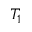<formula> <loc_0><loc_0><loc_500><loc_500>T _ { 1 }</formula> 